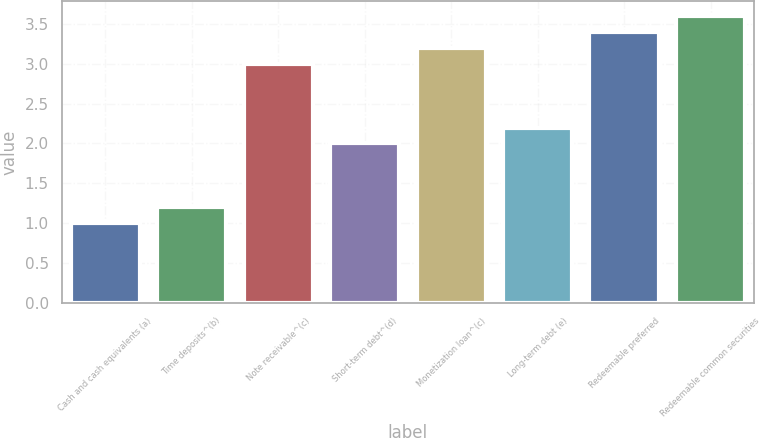Convert chart to OTSL. <chart><loc_0><loc_0><loc_500><loc_500><bar_chart><fcel>Cash and cash equivalents (a)<fcel>Time deposits^(b)<fcel>Note receivable^(c)<fcel>Short-term debt^(d)<fcel>Monetization loan^(c)<fcel>Long-term debt (e)<fcel>Redeemable preferred<fcel>Redeemable common securities<nl><fcel>1<fcel>1.2<fcel>3<fcel>2<fcel>3.2<fcel>2.2<fcel>3.4<fcel>3.6<nl></chart> 